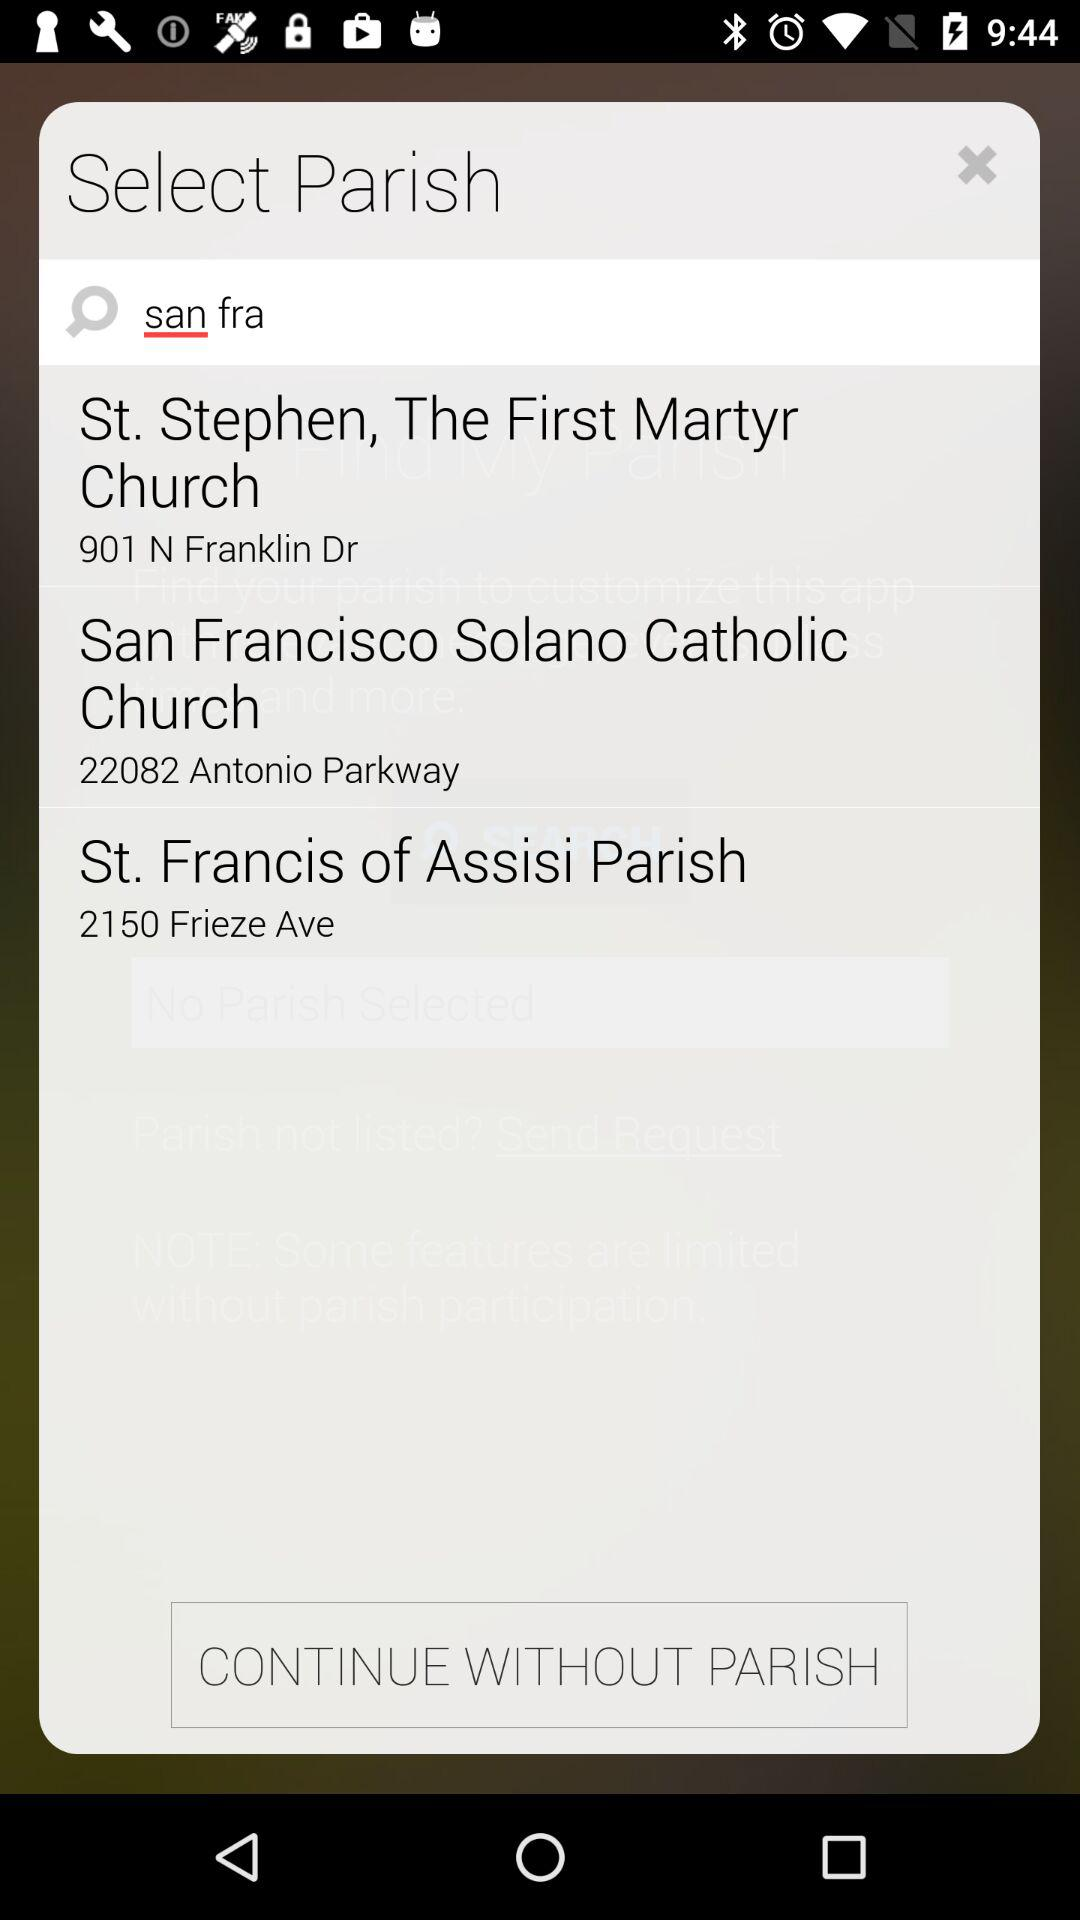What is the name of the application?
When the provided information is insufficient, respond with <no answer>. <no answer> 